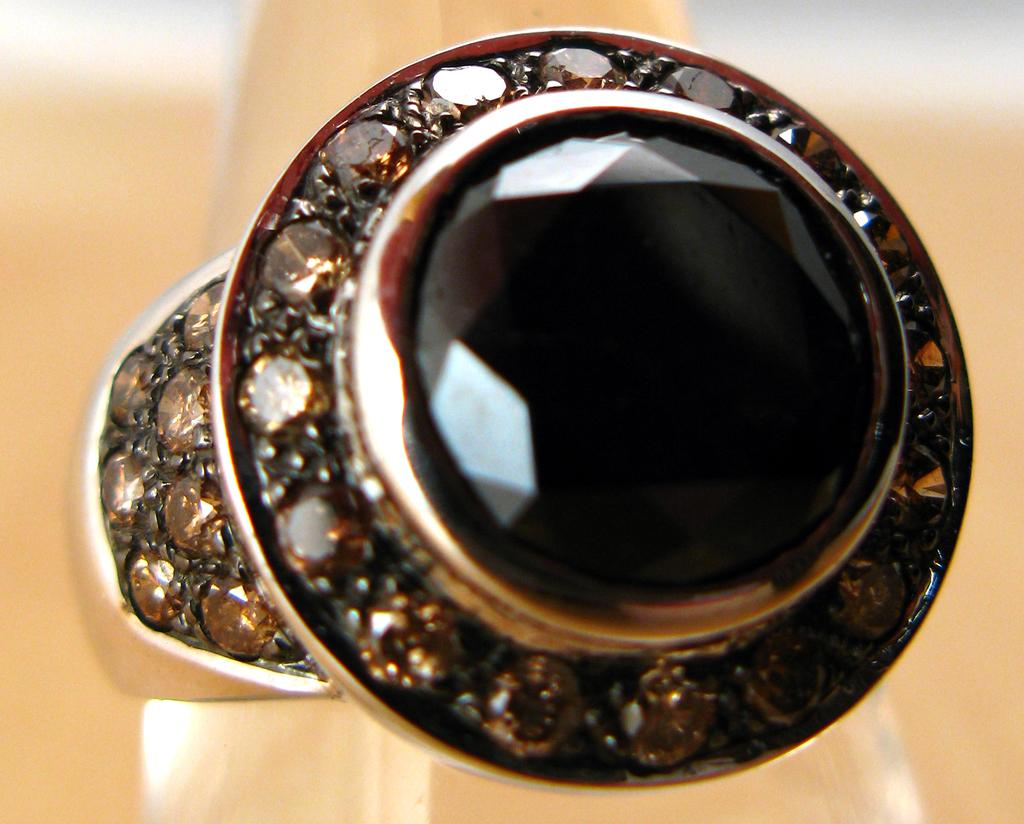What type of objects can be seen in the image? There are colorful stones in the image. What else is present in the image besides the stones? There is a wall in the image. Can you describe the wall in the image? The description of the wall is not available in the provided facts. How many ants are crawling on the jeans in the image? There are no ants or jeans present in the image; it only features colorful stones and a wall. 